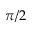Convert formula to latex. <formula><loc_0><loc_0><loc_500><loc_500>\pi / 2</formula> 